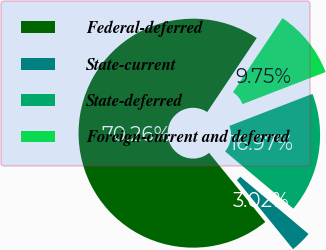Convert chart. <chart><loc_0><loc_0><loc_500><loc_500><pie_chart><fcel>Federal-deferred<fcel>State-current<fcel>State-deferred<fcel>Foreign-current and deferred<nl><fcel>70.26%<fcel>3.02%<fcel>16.97%<fcel>9.75%<nl></chart> 